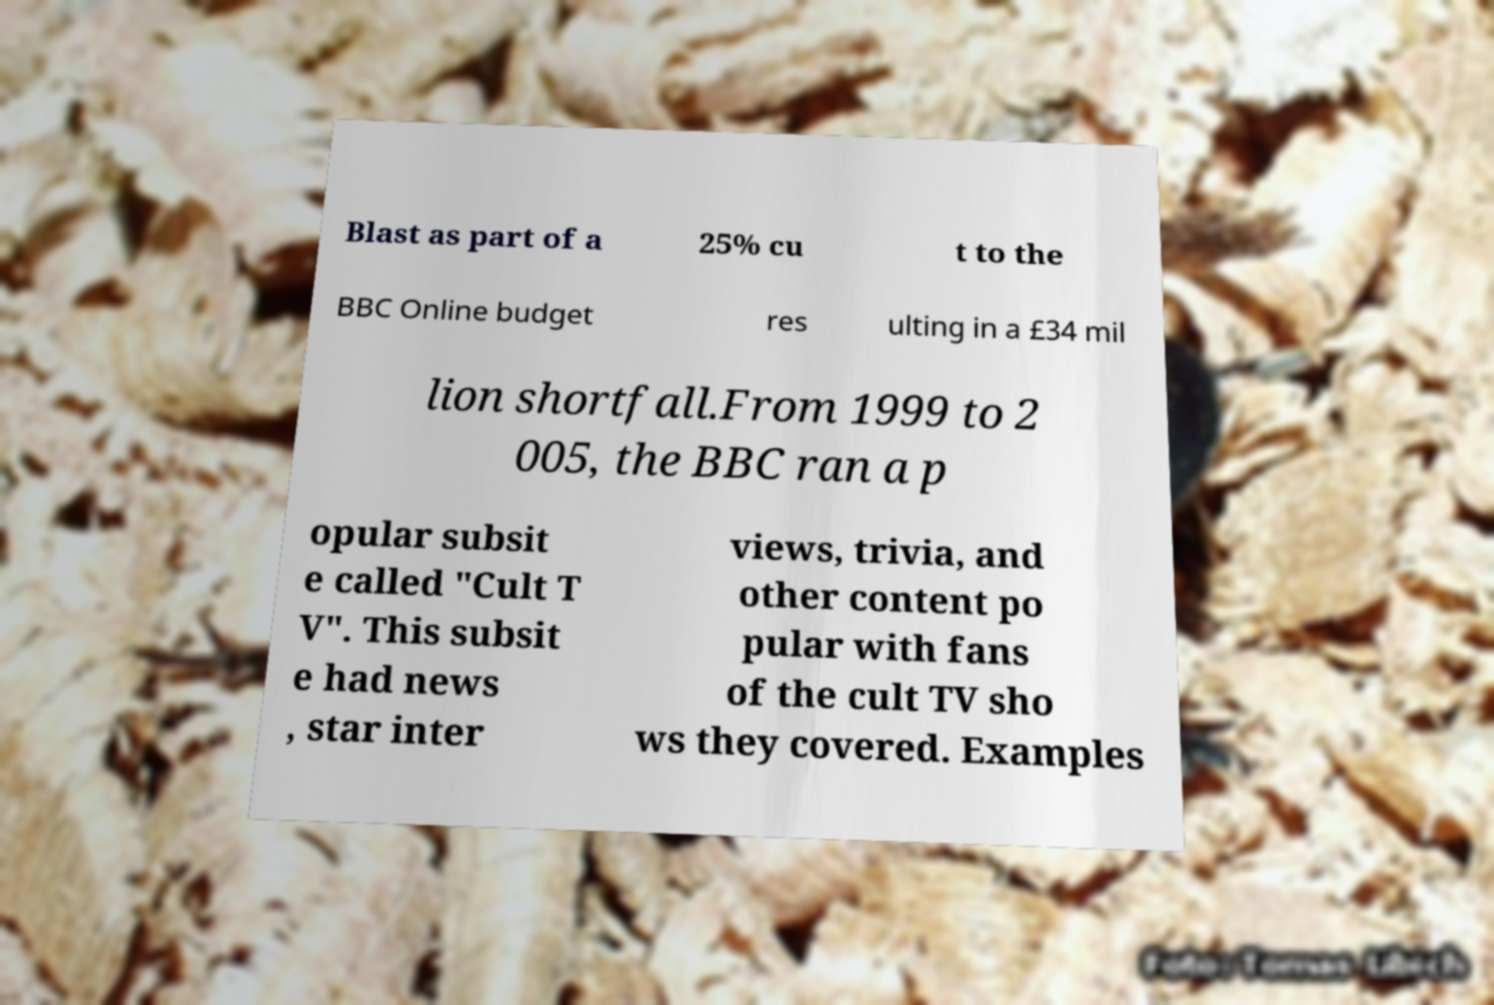What messages or text are displayed in this image? I need them in a readable, typed format. Blast as part of a 25% cu t to the BBC Online budget res ulting in a £34 mil lion shortfall.From 1999 to 2 005, the BBC ran a p opular subsit e called "Cult T V". This subsit e had news , star inter views, trivia, and other content po pular with fans of the cult TV sho ws they covered. Examples 